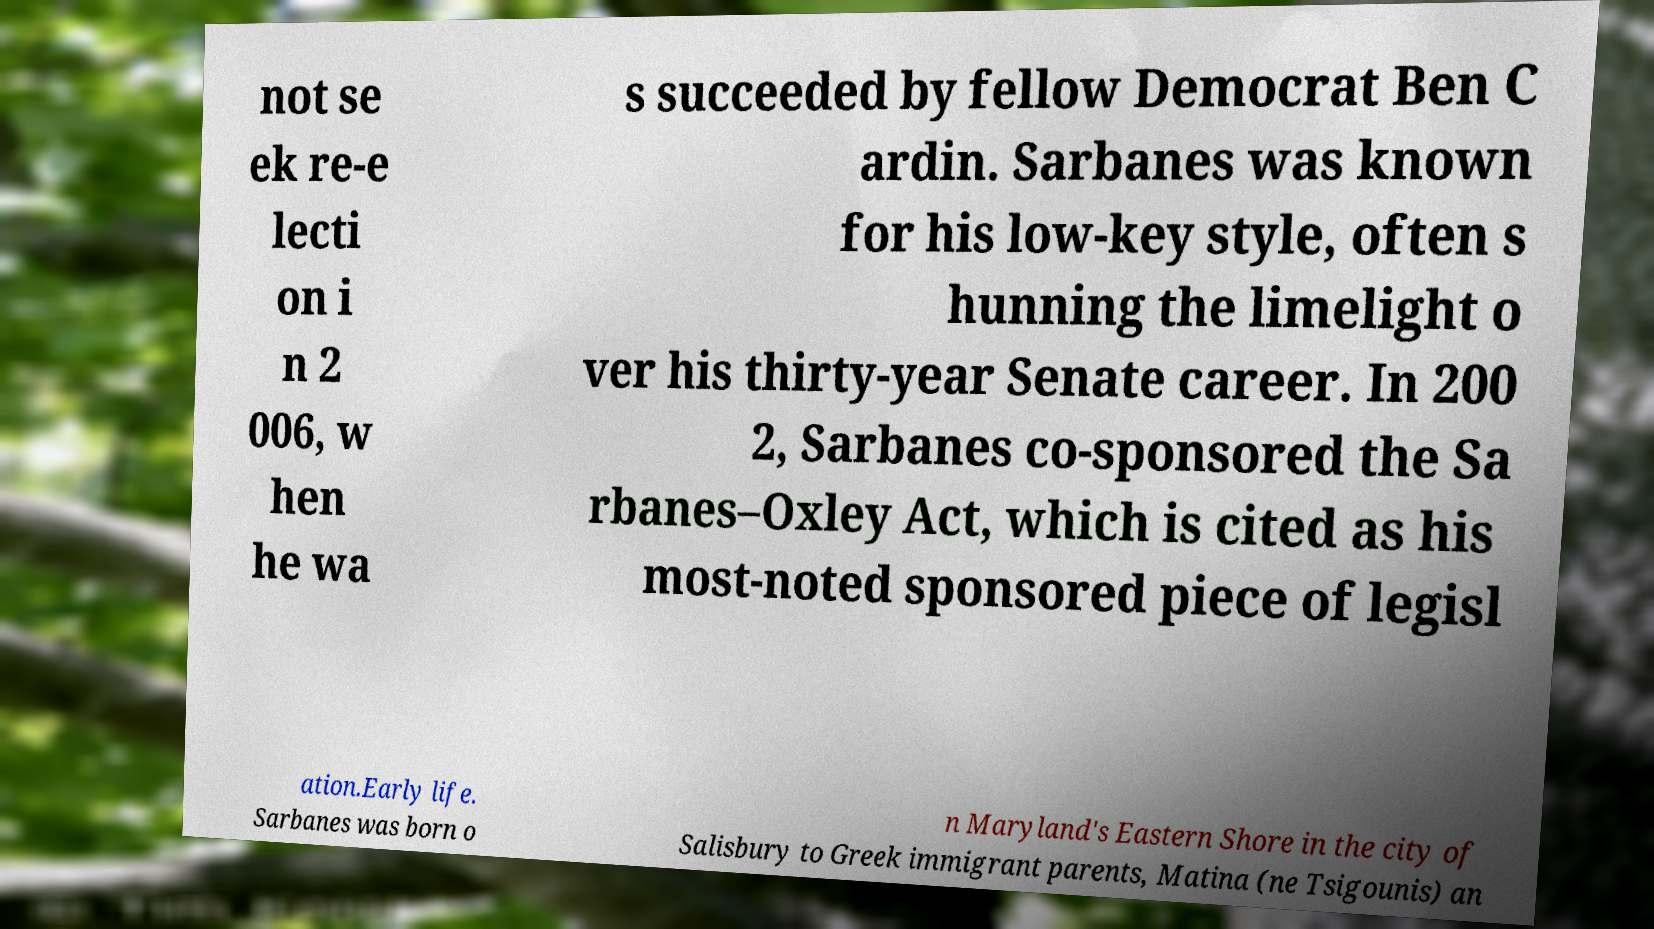Please identify and transcribe the text found in this image. not se ek re-e lecti on i n 2 006, w hen he wa s succeeded by fellow Democrat Ben C ardin. Sarbanes was known for his low-key style, often s hunning the limelight o ver his thirty-year Senate career. In 200 2, Sarbanes co-sponsored the Sa rbanes–Oxley Act, which is cited as his most-noted sponsored piece of legisl ation.Early life. Sarbanes was born o n Maryland's Eastern Shore in the city of Salisbury to Greek immigrant parents, Matina (ne Tsigounis) an 